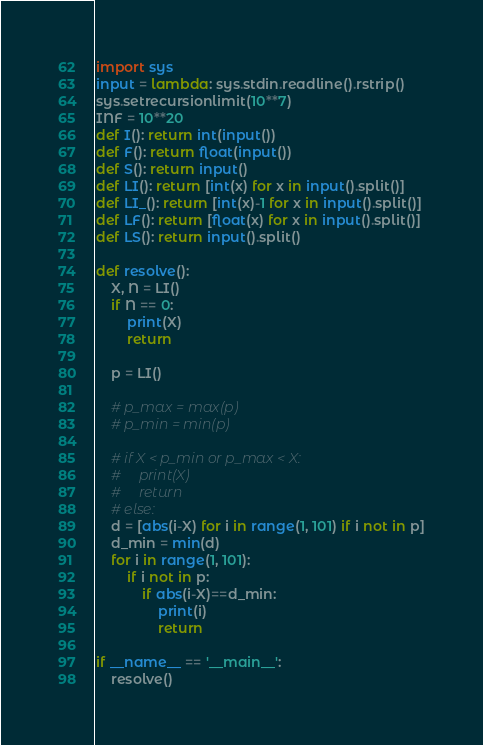<code> <loc_0><loc_0><loc_500><loc_500><_Python_>import sys
input = lambda: sys.stdin.readline().rstrip() 
sys.setrecursionlimit(10**7)
INF = 10**20
def I(): return int(input())
def F(): return float(input())
def S(): return input()
def LI(): return [int(x) for x in input().split()]
def LI_(): return [int(x)-1 for x in input().split()]
def LF(): return [float(x) for x in input().split()]
def LS(): return input().split()

def resolve():
    X, N = LI()
    if N == 0:
        print(X)
        return

    p = LI()

    # p_max = max(p)
    # p_min = min(p)

    # if X < p_min or p_max < X:
    #     print(X)
    #     return
    # else:
    d = [abs(i-X) for i in range(1, 101) if i not in p]
    d_min = min(d)
    for i in range(1, 101):
        if i not in p:
            if abs(i-X)==d_min:
                print(i)
                return

if __name__ == '__main__':
    resolve()
</code> 